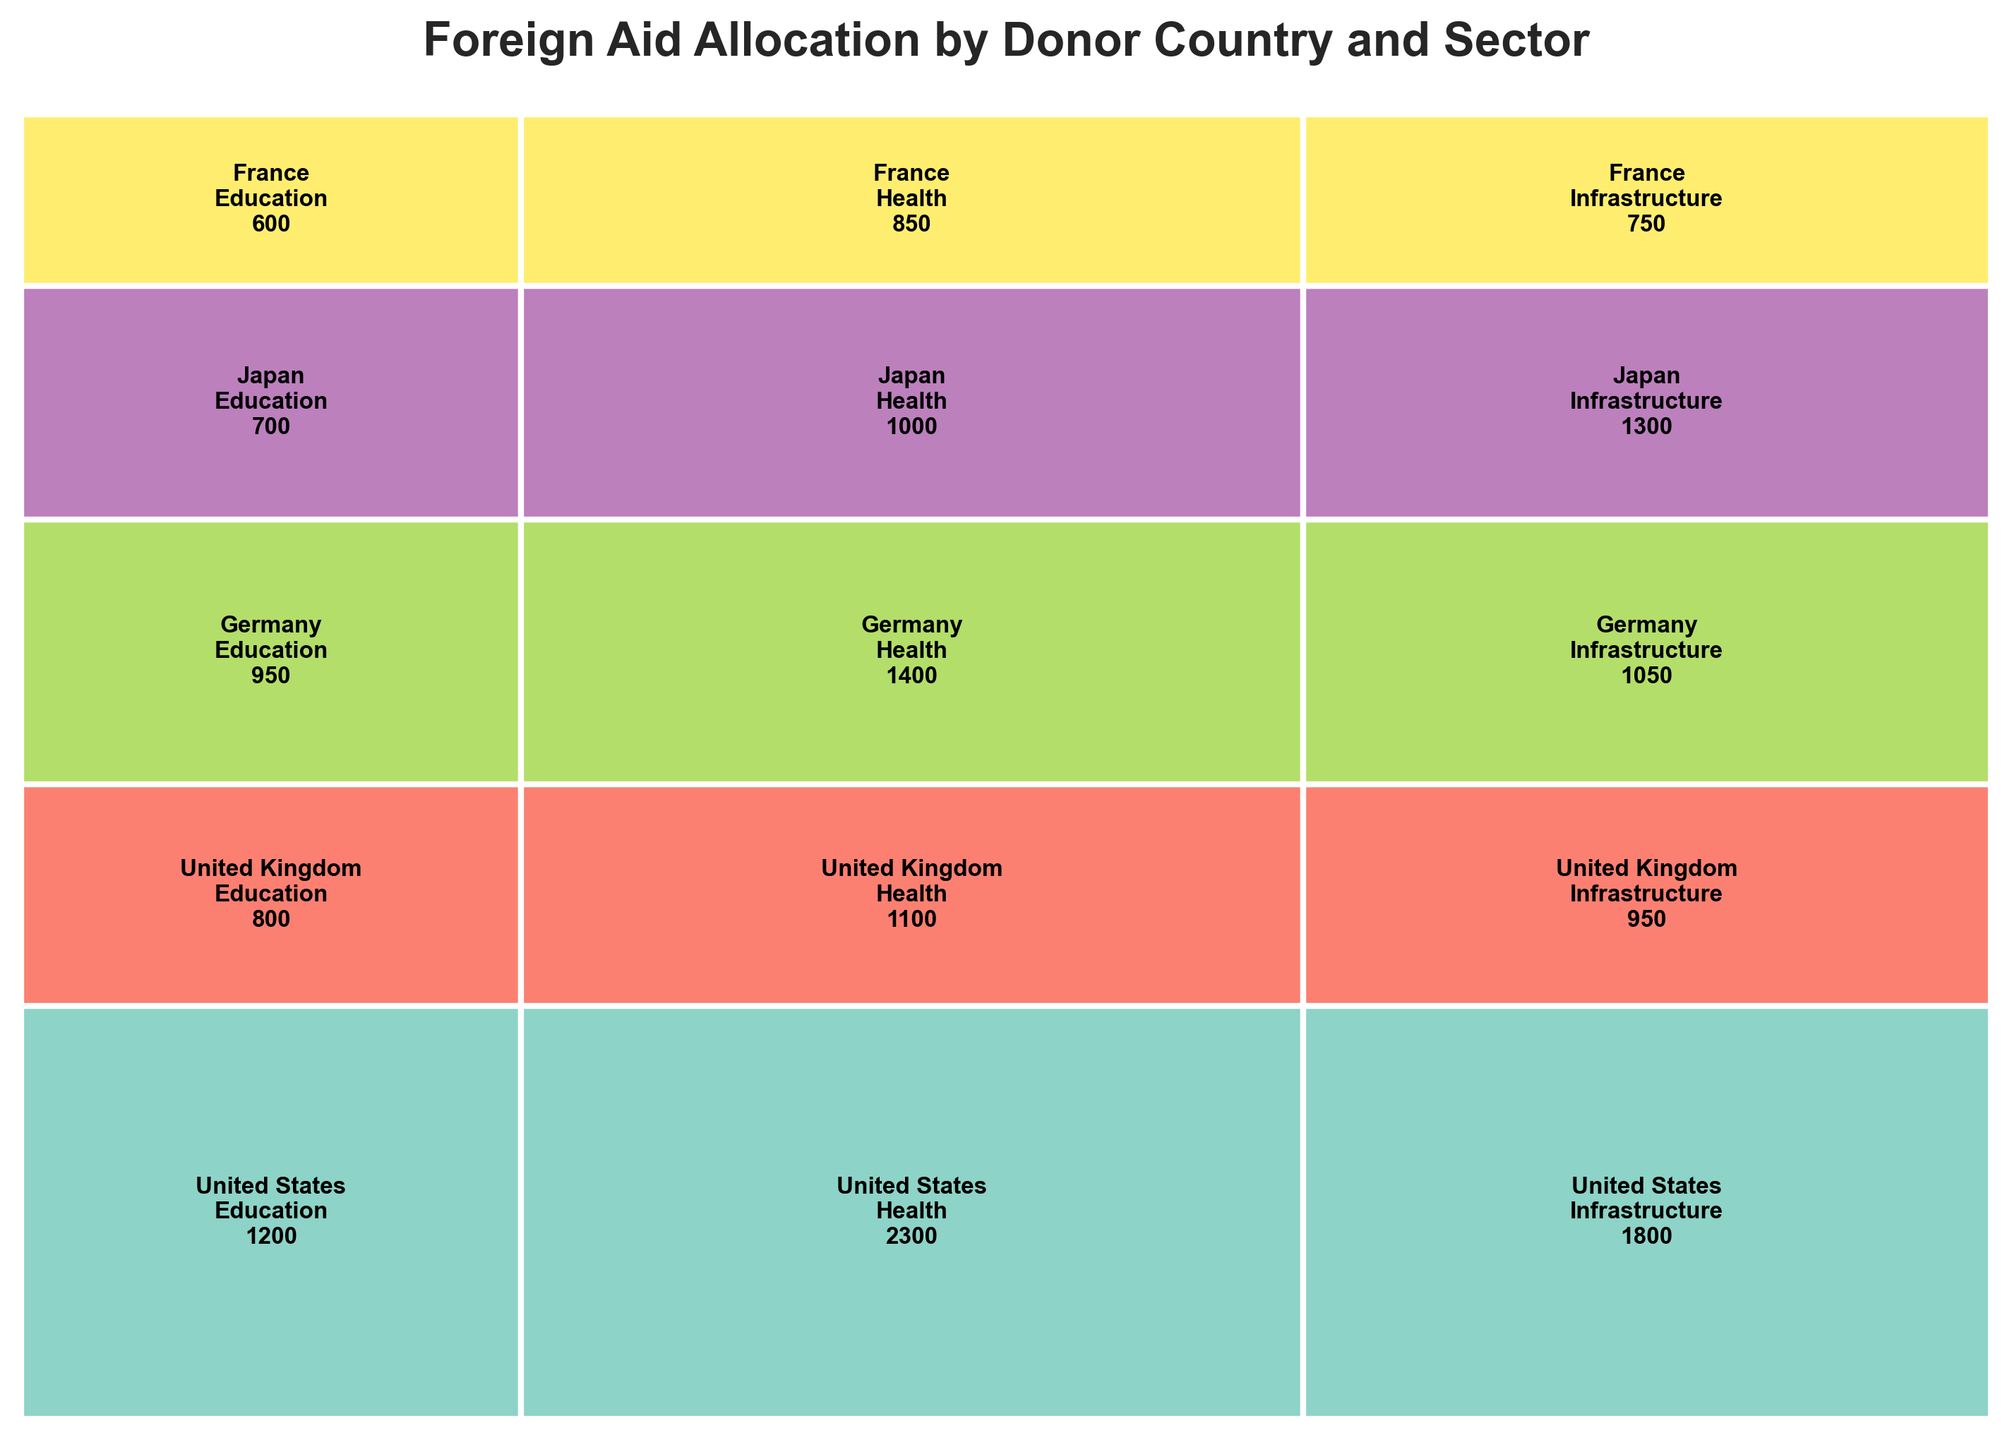What is the title of the figure? The title is usually found at the top of the figure. In this case, it indicates the main topic, which is "Foreign Aid Allocation by Donor Country and Sector".
Answer: Foreign Aid Allocation by Donor Country and Sector Which country has the highest aid amount in the Health sector? Identify the Health sector rectangles, then compare the sizes. The largest rectangle corresponds to the United States, as indicated in the annotated text within the rectangle.
Answer: United States How does the aid amount in the Infrastructure sector compare between the United Kingdom and Japan? Locate the Infrastructure sector rectangles for both the United Kingdom and Japan, then compare the sizes of these rectangles. The United Kingdom's rectangle is smaller than Japan's, as reflected in the annotated text.
Answer: Japan has more Which sector receives the least amount of aid from France? Identify the three sectors for France by looking for the rectangles labeled with France. Compare the sizes, and the smallest one is Education.
Answer: Education What is the total aid amount allocated by the United States? Locate the rectangles representing the United States. Sum up the values annotated within these rectangles (Education: 1200, Health: 2300, Infrastructure: 1800). Total is 1200 + 2300 + 1800 = 5300.
Answer: 5300 How does the aid allocation in the Infrastructure sector from Germany compare to that from France? Locate the Infrastructure sector rectangles for Germany and France. Compare their sizes and the annotated amounts (Germany: 1050, France: 750). Germany’s amount is greater than France’s.
Answer: Germany has more Which country provides the most aid in total? Find the rectangles for each country and sum their sector aid amounts. The country with the highest sum is the United States (5300).
Answer: United States What is the aid amount from Japan in the Education sector compared to Germany in the same sector? Identify the Education sector rectangles for both Japan and Germany. Compare the annotated amounts (Japan: 700, Germany: 950). Germany allocates more aid in this sector.
Answer: Germany allocates more What proportion of the total aid does the Health sector receive from the United Kingdom? Identify the total aid from the United Kingdom (800 + 1100 + 950 = 2850) and the allocated amount in the Health sector (1100). Calculate the proportion (1100 / 2850 ≈ 0.39 or 39%).
Answer: 39% How does the total aid allocation compare between the United Kingdom and Germany? Sum the aid amounts for all sectors in both countries. United Kingdom (800 + 1100 + 950 = 2850), Germany (950 + 1400 + 1050 = 3400). Germany allocates more total aid than the United Kingdom.
Answer: Germany allocates more 